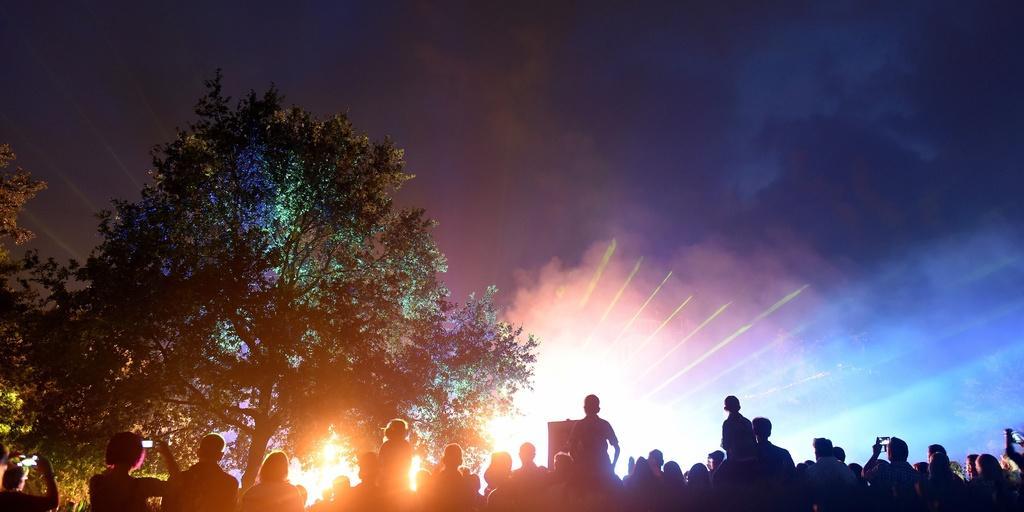Can you describe this image briefly? In this picture we can see a group of people, trees, fire and some objects. In the background we can see the sky. 